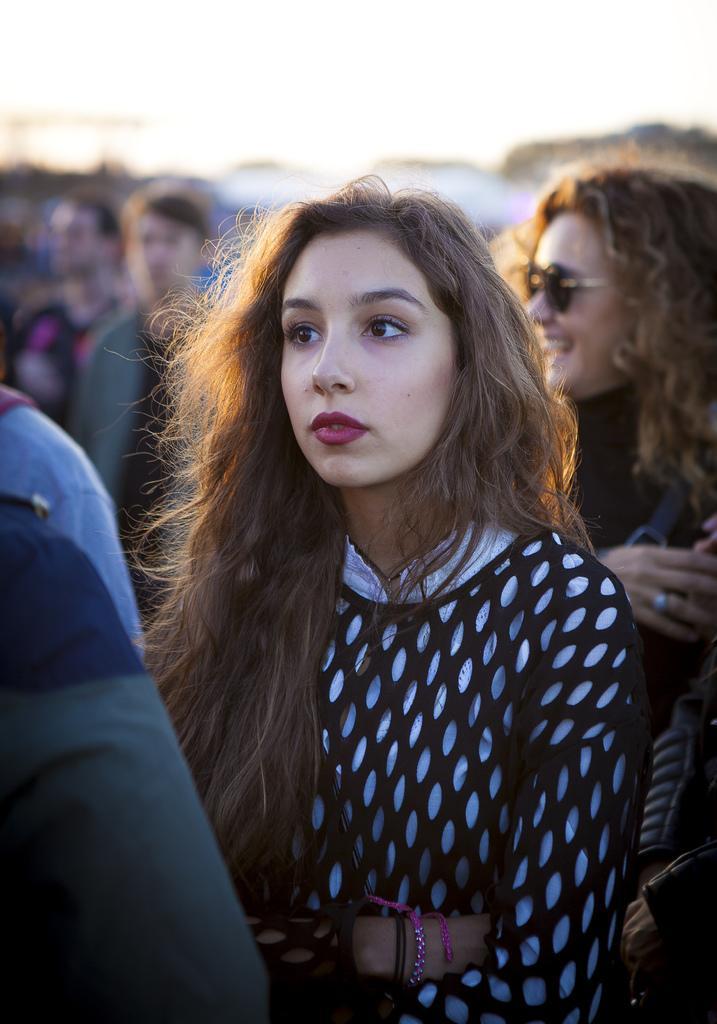Could you give a brief overview of what you see in this image? In this image we can see a woman wearing black and white dress. The background of the image is slightly blurred, where we can see a few more people. 